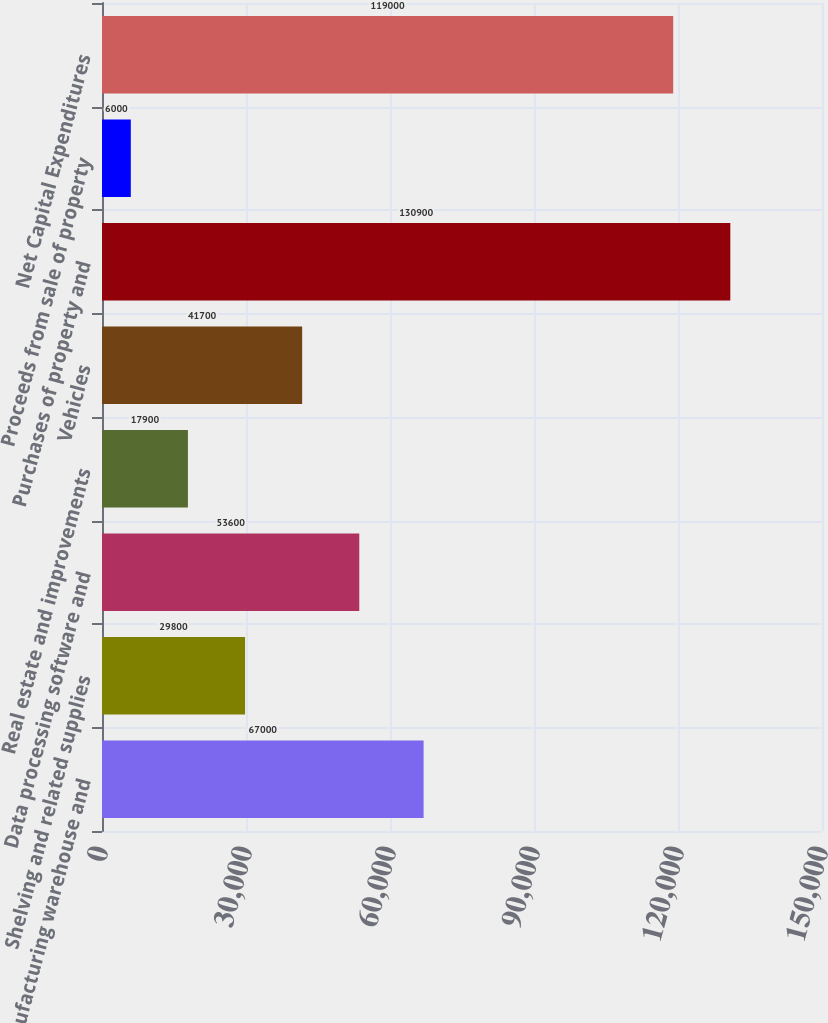Convert chart. <chart><loc_0><loc_0><loc_500><loc_500><bar_chart><fcel>Manufacturing warehouse and<fcel>Shelving and related supplies<fcel>Data processing software and<fcel>Real estate and improvements<fcel>Vehicles<fcel>Purchases of property and<fcel>Proceeds from sale of property<fcel>Net Capital Expenditures<nl><fcel>67000<fcel>29800<fcel>53600<fcel>17900<fcel>41700<fcel>130900<fcel>6000<fcel>119000<nl></chart> 